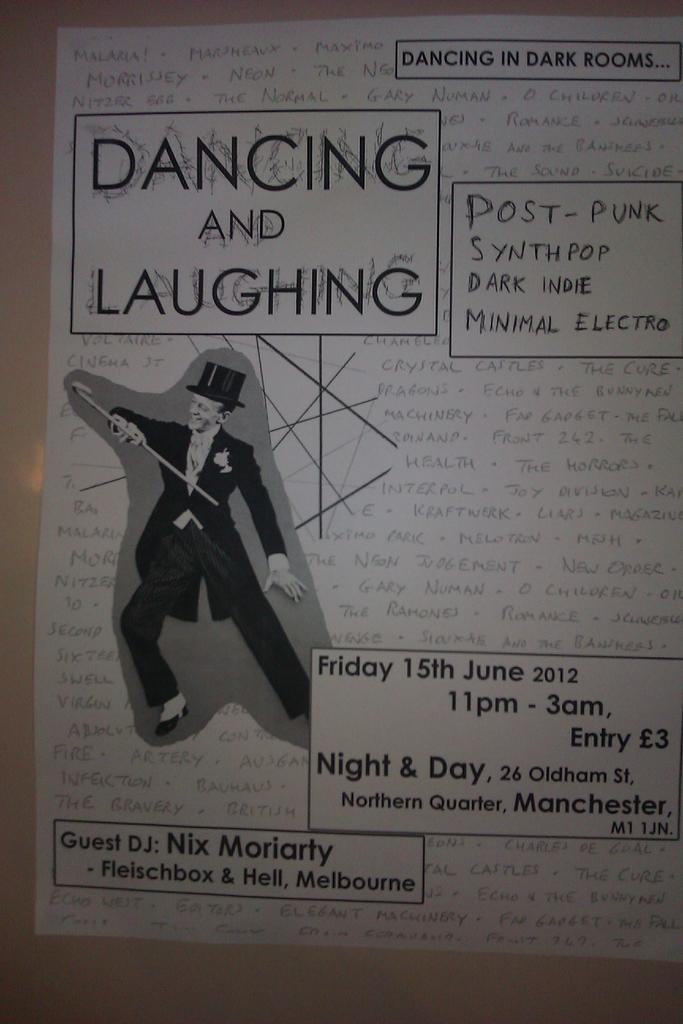<image>
Create a compact narrative representing the image presented. A club flyer promises different types of music and a guest DJ. 